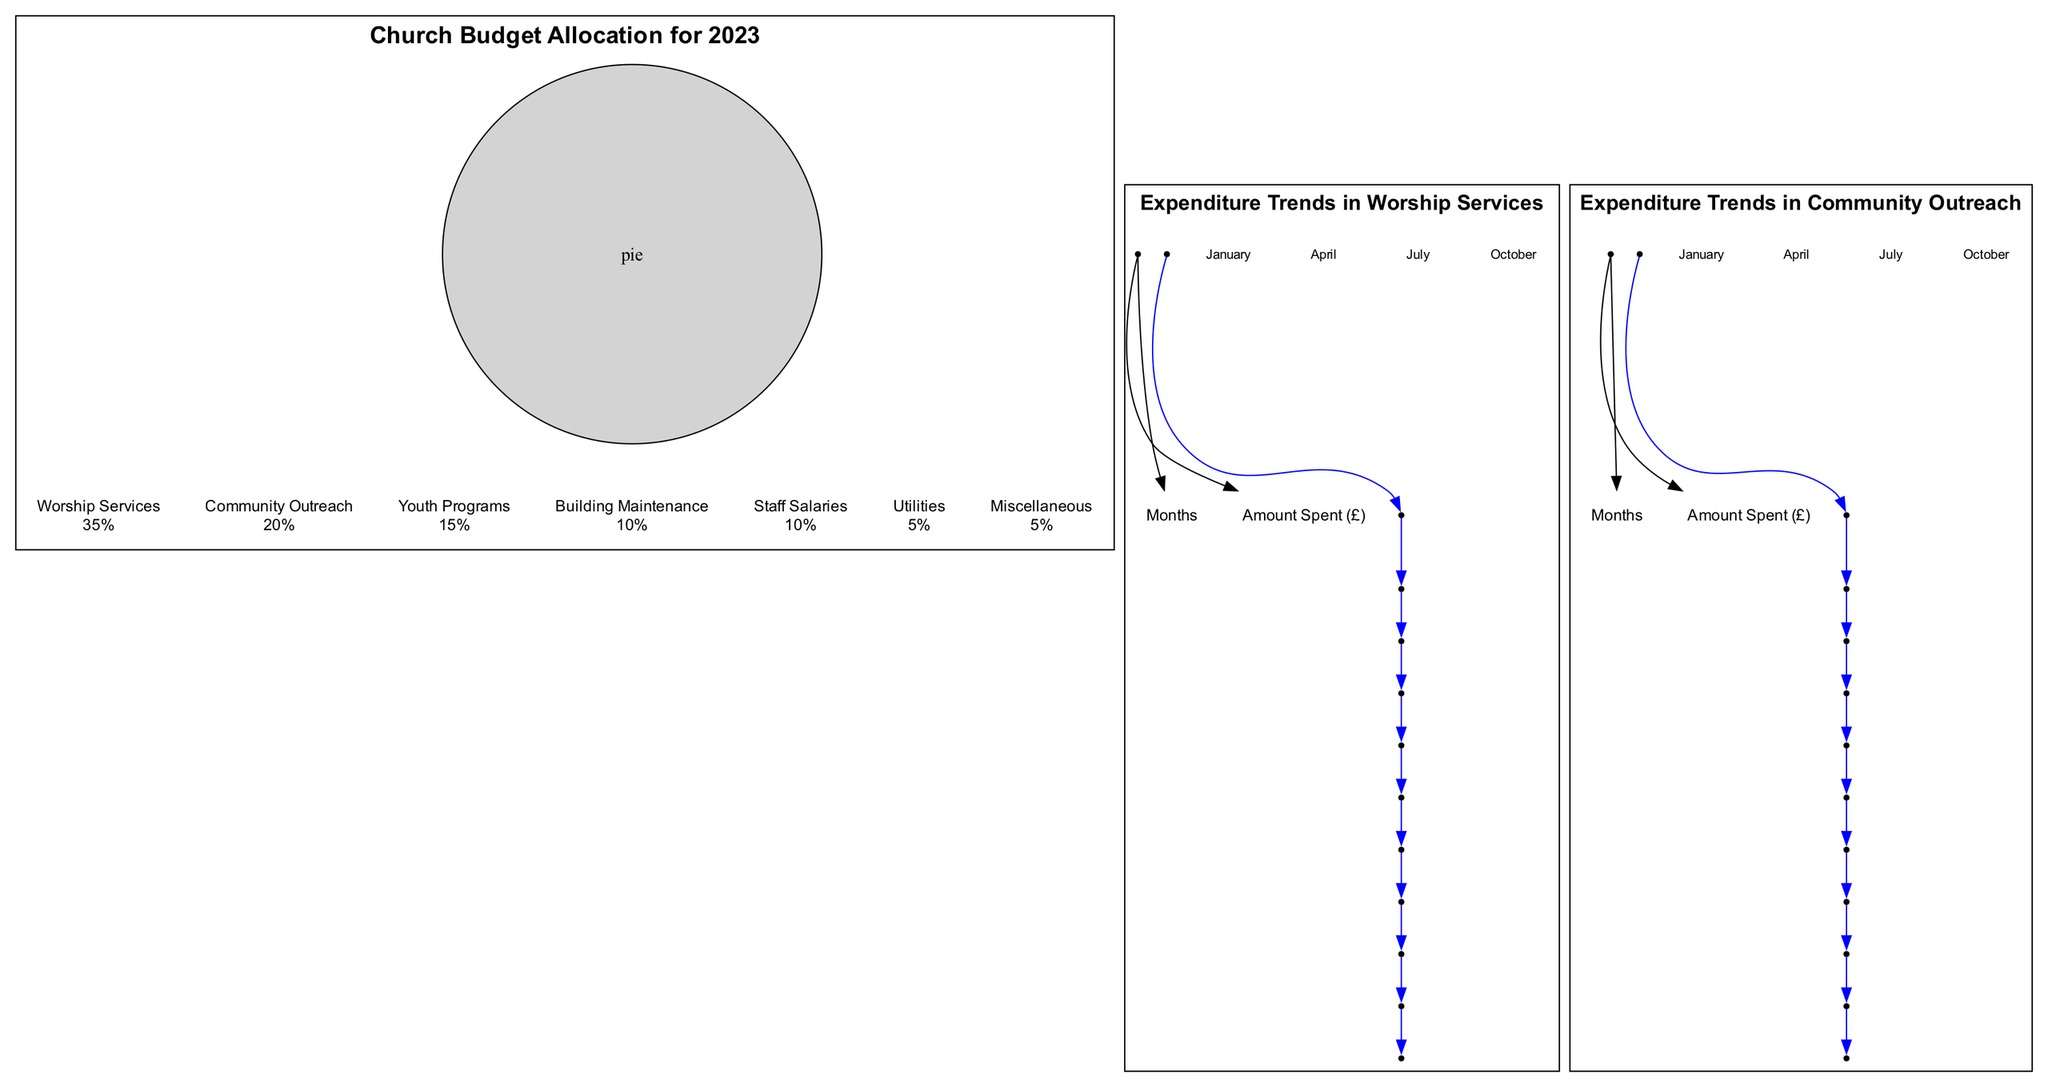What is the largest allocation in the pie chart? The pie chart shows the different allocations for the church budget. By examining the slices, it is clear that "Worship Services" has the largest portion at 35%.
Answer: Worship Services What percentage is allocated to Building Maintenance? The pie chart represents multiple budget categories including Building Maintenance. This slice accounts for 10% of the total budget allocation.
Answer: 10% Which month had the highest expenditure in Worship Services? The line graph for Worship Services outlines monthly expenditures. Scanning through the data points, the highest amount is found in December, where £3900 was spent.
Answer: 3900 What trend is observed in Community Outreach expenditures from January to December? A review of the expenditure trends in the Community Outreach line graph reveals a generally decreasing trend, with amounts fluctuating but mostly declining through the year, starting at £1500 in January and ending at £1300 in December.
Answer: Decreasing How much was spent on Youth Programs compared to Utilities? To compare, we can reference the pie chart slices. Youth Programs received 15% while Utilities received 5%, indicating Youth Programs received more than Utilities by 10%.
Answer: 10% What was the total amount spent on Worship Services across all months? We sum the amounts for each month from the Worship Services line graph. The totals are: £3000 + £2800 + £3200 + £3100 + £3000 + £3300 + £3400 + £3500 + £3600 + £3700 + £3800 + £3900 which equals £40,800.
Answer: 40800 In which month was the expenditure in Community Outreach the lowest, and what was the amount? Looking through the expenditures for Community Outreach, by analyzing each monthly value, the lowest amount occurs in December, with £1300 spent.
Answer: 1300 How many categories of expenditure are shown in the pie chart? The pie chart depicts different segments of budget allocation. By counting the slices (Worship Services, Community Outreach, Youth Programs, Building Maintenance, Staff Salaries, Utilities, Miscellaneous), we find there are seven distinct categories.
Answer: 7 Which activities have the same percentage allocation? Analyzing the pie chart slices, both Staff Salaries and Utilities are allocated 10% each, while Miscellaneous is similarly allocated 5%.
Answer: Staff Salaries and Utilities (10% each) and Miscellaneous (5%) 